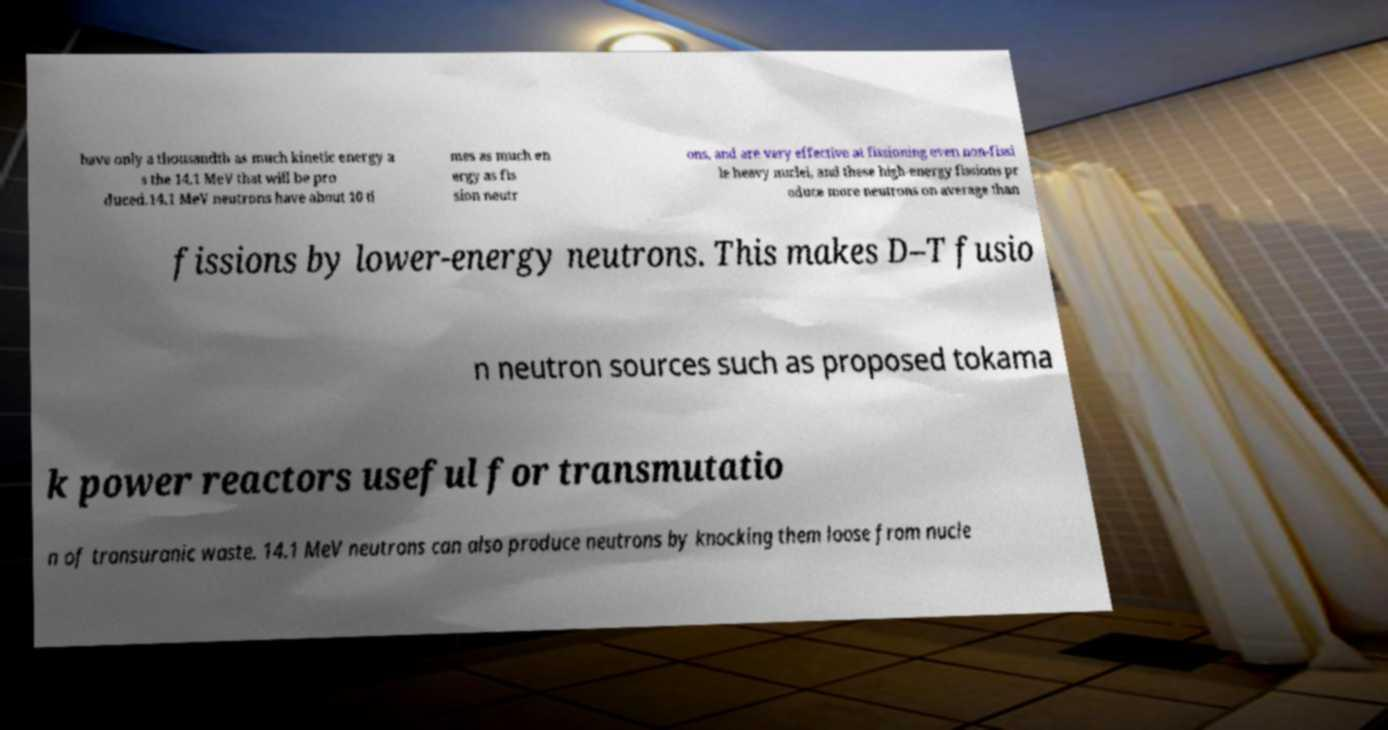For documentation purposes, I need the text within this image transcribed. Could you provide that? have only a thousandth as much kinetic energy a s the 14.1 MeV that will be pro duced.14.1 MeV neutrons have about 10 ti mes as much en ergy as fis sion neutr ons, and are very effective at fissioning even non-fissi le heavy nuclei, and these high-energy fissions pr oduce more neutrons on average than fissions by lower-energy neutrons. This makes D–T fusio n neutron sources such as proposed tokama k power reactors useful for transmutatio n of transuranic waste. 14.1 MeV neutrons can also produce neutrons by knocking them loose from nucle 